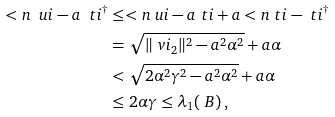<formula> <loc_0><loc_0><loc_500><loc_500>< n { \ u i - a \ t i ^ { \dagger } } & \leq < n { \ u i - a \ t i } + a < n { \ t i - \ t i ^ { \dagger } } \\ & = \sqrt { \| \ v i _ { 2 } \| ^ { 2 } - a ^ { 2 } \alpha ^ { 2 } } + a \alpha \\ & < \sqrt { 2 \alpha ^ { 2 } \gamma ^ { 2 } - a ^ { 2 } \alpha ^ { 2 } } + a \alpha \\ & \leq 2 \alpha \gamma \leq \lambda _ { 1 } ( \ B ) \, ,</formula> 